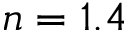<formula> <loc_0><loc_0><loc_500><loc_500>n = 1 . 4</formula> 